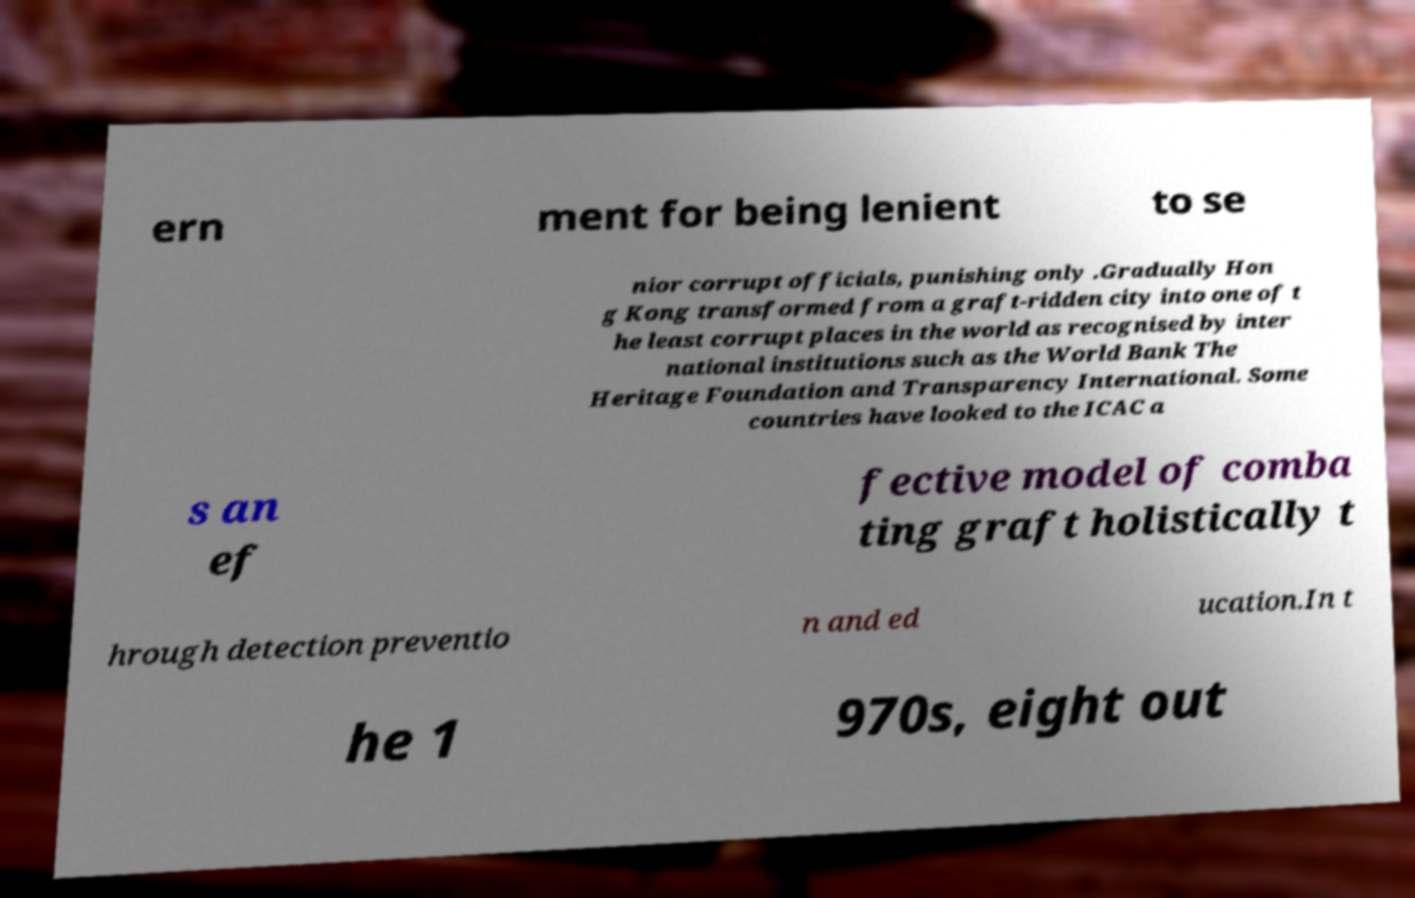Please identify and transcribe the text found in this image. ern ment for being lenient to se nior corrupt officials, punishing only .Gradually Hon g Kong transformed from a graft-ridden city into one of t he least corrupt places in the world as recognised by inter national institutions such as the World Bank The Heritage Foundation and Transparency International. Some countries have looked to the ICAC a s an ef fective model of comba ting graft holistically t hrough detection preventio n and ed ucation.In t he 1 970s, eight out 